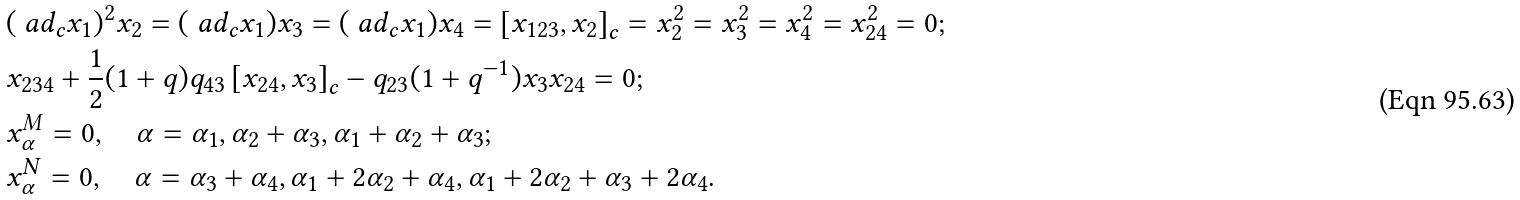Convert formula to latex. <formula><loc_0><loc_0><loc_500><loc_500>& ( \ a d _ { c } x _ { 1 } ) ^ { 2 } x _ { 2 } = ( \ a d _ { c } x _ { 1 } ) x _ { 3 } = ( \ a d _ { c } x _ { 1 } ) x _ { 4 } = \left [ x _ { 1 2 3 } , x _ { 2 } \right ] _ { c } = x _ { 2 } ^ { 2 } = x _ { 3 } ^ { 2 } = x _ { 4 } ^ { 2 } = x _ { 2 4 } ^ { 2 } = 0 ; \\ & x _ { 2 3 4 } + \frac { 1 } { 2 } ( 1 + q ) q _ { 4 3 } \left [ x _ { 2 4 } , x _ { 3 } \right ] _ { c } - q _ { 2 3 } ( 1 + q ^ { - 1 } ) x _ { 3 } x _ { 2 4 } = 0 ; \\ & x _ { \alpha } ^ { M } = 0 , \quad \alpha = \alpha _ { 1 } , \alpha _ { 2 } + \alpha _ { 3 } , \alpha _ { 1 } + \alpha _ { 2 } + \alpha _ { 3 } ; \\ & x _ { \alpha } ^ { N } = 0 , \quad \alpha = \alpha _ { 3 } + \alpha _ { 4 } , \alpha _ { 1 } + 2 \alpha _ { 2 } + \alpha _ { 4 } , \alpha _ { 1 } + 2 \alpha _ { 2 } + \alpha _ { 3 } + 2 \alpha _ { 4 } .</formula> 